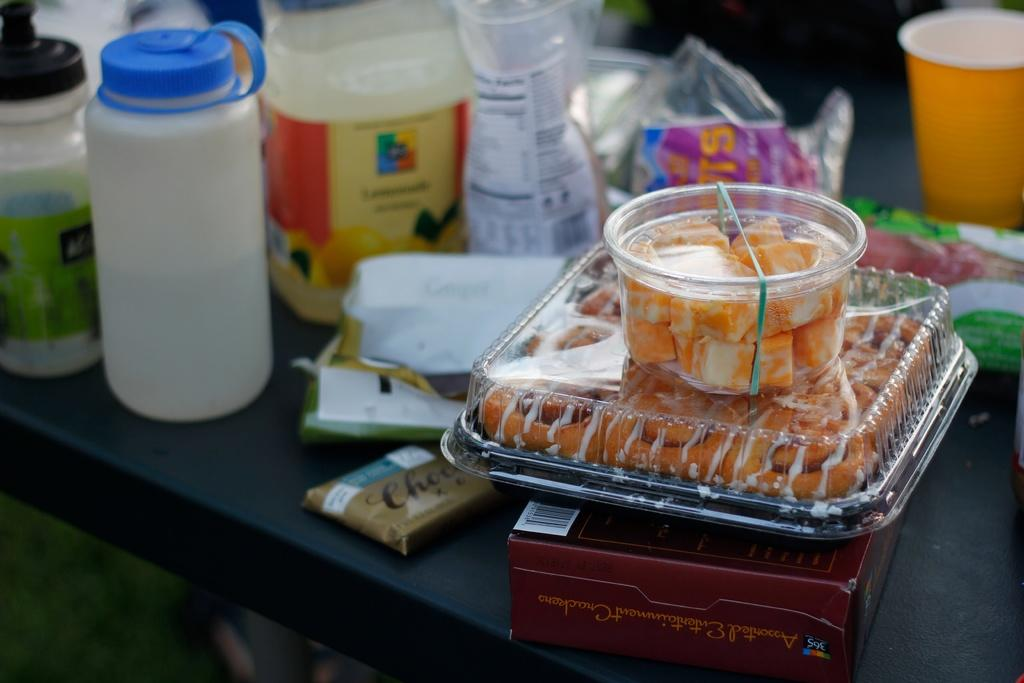What is the main piece of furniture in the image? There is a table in the image. What types of items can be seen on the table? There are different types of bottles and boxes on the table. What else is present on the table besides bottles and boxes? There are eatable things on the table. What type of vest is being used as a vessel for the eatable things on the table? There is no vest present in the image, and no vest is being used as a vessel for the eatable things. 